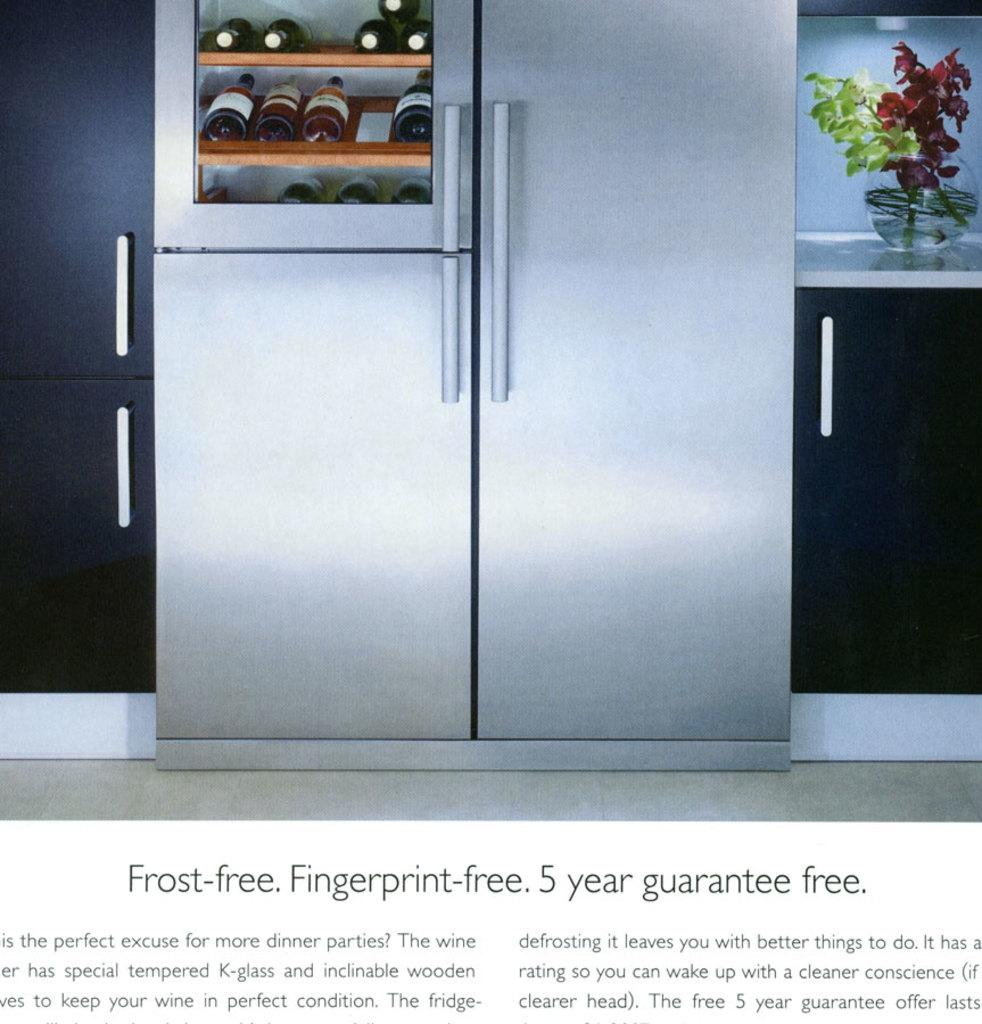<image>
Create a compact narrative representing the image presented. A fridge with wine bottles on display and an ad offering 5 year guarantee. 